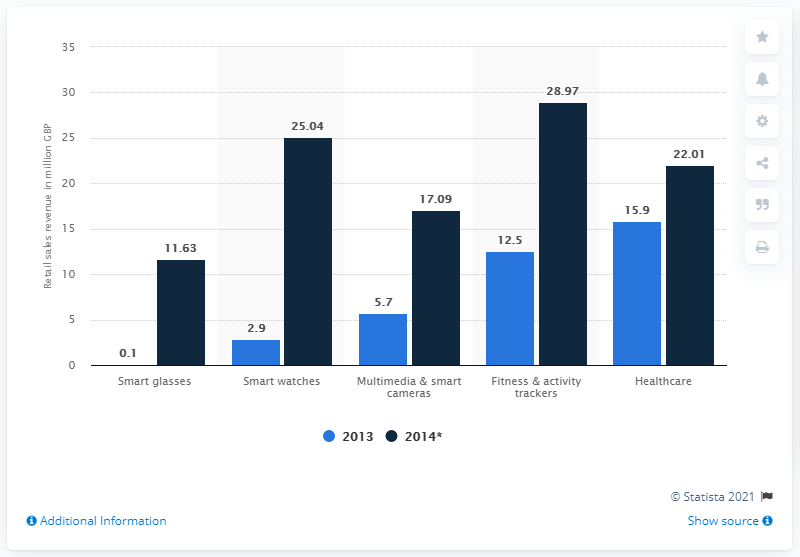Highlight a few significant elements in this photo. The chart shows values for several categories on the x-axis, with some categories having values of 5.7 and 17.09. One of these categories is "Multimedia & smart cameras," which likely contains products such as smart home cameras or wearable cameras. The average of 2014 is 20.95, based on a survey of 2014. In 2013, the sales revenue for fitness and activity trackers was 12.5 billion dollars. 